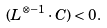Convert formula to latex. <formula><loc_0><loc_0><loc_500><loc_500>( L ^ { \otimes - 1 } \cdot C ) < 0 .</formula> 